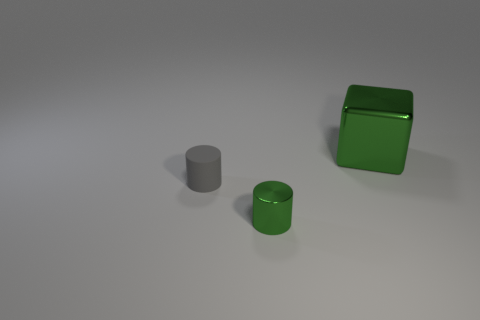Is there any other thing that is the same size as the green cube?
Make the answer very short. No. What is the color of the other cylinder that is the same size as the gray cylinder?
Ensure brevity in your answer.  Green. Is the size of the metal cube the same as the green cylinder?
Ensure brevity in your answer.  No. How many metallic blocks are behind the small gray object?
Offer a terse response. 1. What number of objects are objects that are behind the gray object or green metal cylinders?
Your response must be concise. 2. Is the number of metal cylinders in front of the large shiny thing greater than the number of green metal things in front of the small gray thing?
Make the answer very short. No. There is a metal thing that is the same color as the shiny block; what size is it?
Offer a terse response. Small. Does the rubber cylinder have the same size as the green shiny object that is to the left of the big shiny object?
Provide a succinct answer. Yes. How many spheres are either cyan objects or big green metallic objects?
Your response must be concise. 0. There is a cylinder that is made of the same material as the cube; what size is it?
Ensure brevity in your answer.  Small. 